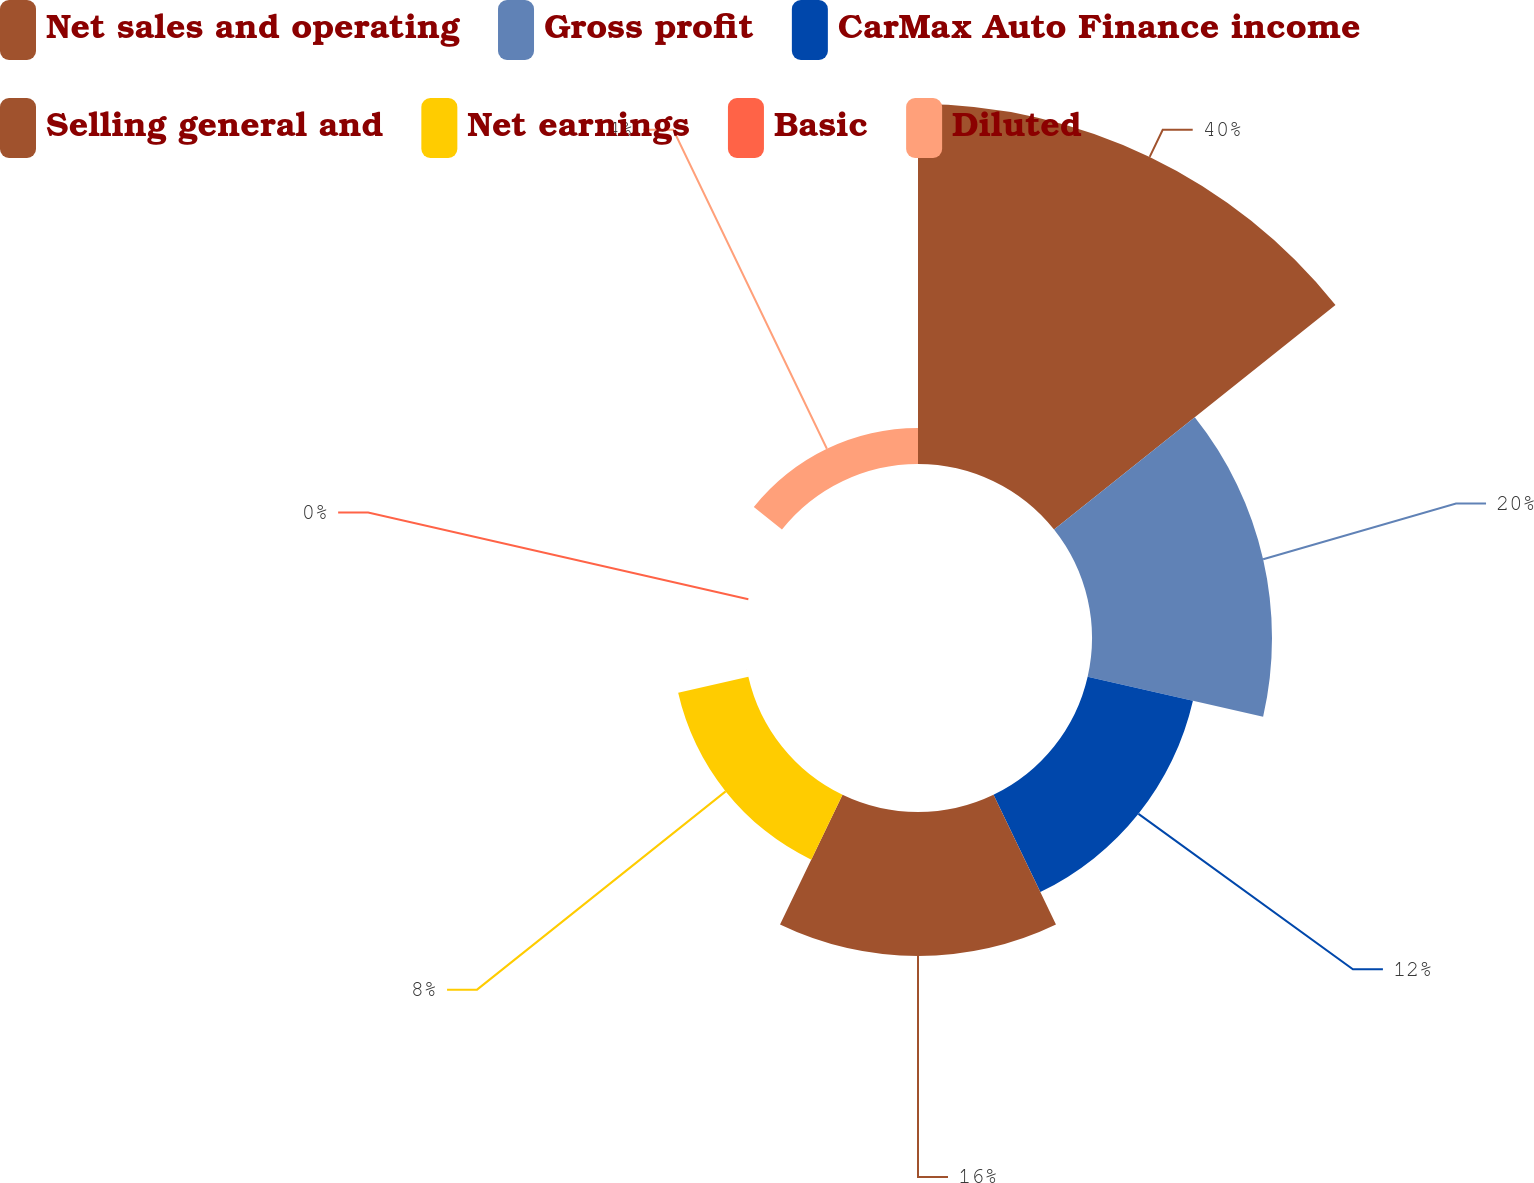Convert chart to OTSL. <chart><loc_0><loc_0><loc_500><loc_500><pie_chart><fcel>Net sales and operating<fcel>Gross profit<fcel>CarMax Auto Finance income<fcel>Selling general and<fcel>Net earnings<fcel>Basic<fcel>Diluted<nl><fcel>40.0%<fcel>20.0%<fcel>12.0%<fcel>16.0%<fcel>8.0%<fcel>0.0%<fcel>4.0%<nl></chart> 